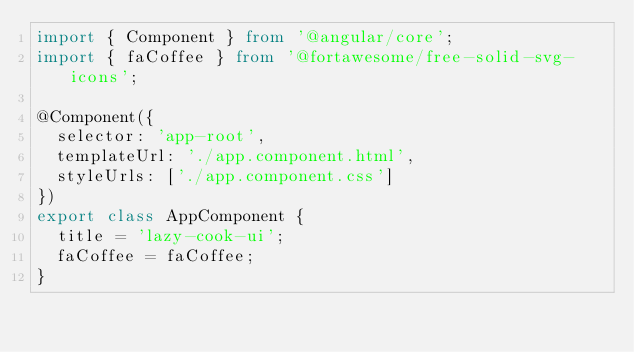Convert code to text. <code><loc_0><loc_0><loc_500><loc_500><_TypeScript_>import { Component } from '@angular/core';
import { faCoffee } from '@fortawesome/free-solid-svg-icons';

@Component({
  selector: 'app-root',
  templateUrl: './app.component.html',
  styleUrls: ['./app.component.css']
})
export class AppComponent {
  title = 'lazy-cook-ui';
  faCoffee = faCoffee;
}
</code> 